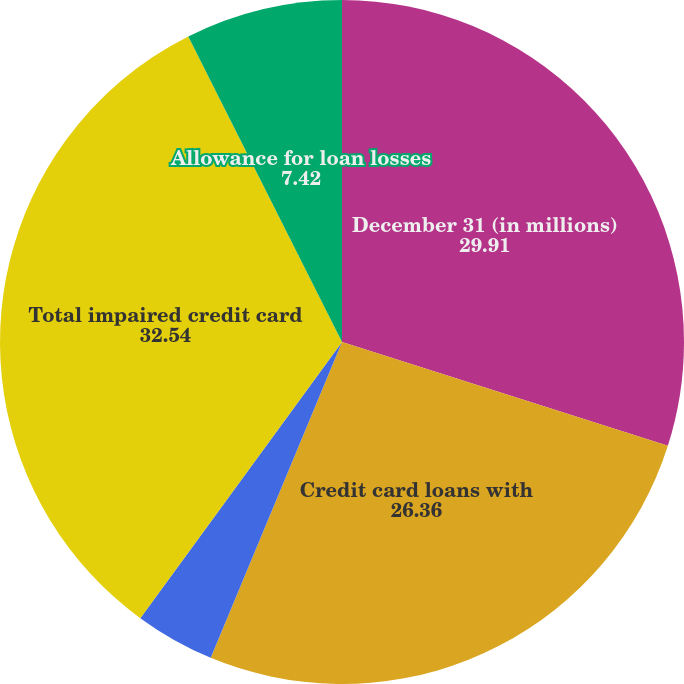<chart> <loc_0><loc_0><loc_500><loc_500><pie_chart><fcel>December 31 (in millions)<fcel>Credit card loans with<fcel>Modified credit card loans<fcel>Total impaired credit card<fcel>Allowance for loan losses<nl><fcel>29.91%<fcel>26.36%<fcel>3.77%<fcel>32.54%<fcel>7.42%<nl></chart> 